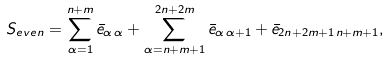<formula> <loc_0><loc_0><loc_500><loc_500>S _ { e v e n } = \sum _ { \alpha = 1 } ^ { n + m } \bar { e } _ { \alpha \, \alpha } + \sum _ { \alpha = n + m + 1 } ^ { 2 n + 2 m } \bar { e } _ { \alpha \, \alpha + 1 } + \bar { e } _ { 2 n + 2 m + 1 \, n + m + 1 } ,</formula> 